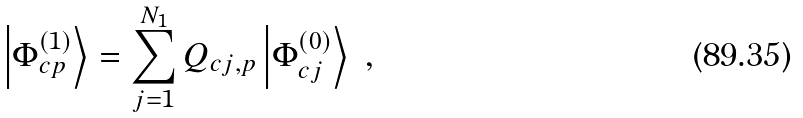<formula> <loc_0><loc_0><loc_500><loc_500>\left | \Phi ^ { ( 1 ) } _ { { c } p } \right \rangle = \sum ^ { N _ { 1 } } _ { j = 1 } Q _ { { c } j , p } \left | \Phi ^ { ( 0 ) } _ { { c } j } \right \rangle \ ,</formula> 